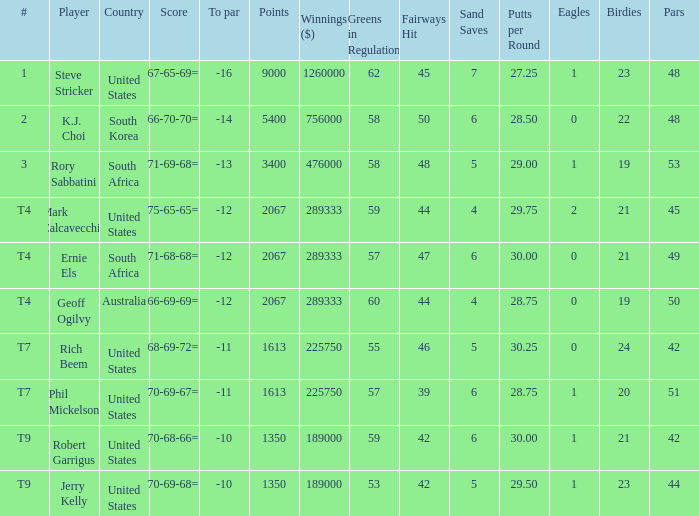Name the number of points for south korea 1.0. 